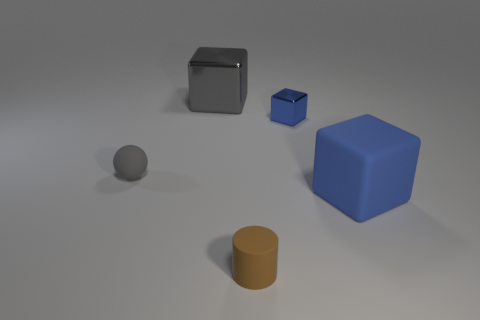Add 4 green metallic cylinders. How many objects exist? 9 Subtract all cylinders. How many objects are left? 4 Add 5 tiny red metallic spheres. How many tiny red metallic spheres exist? 5 Subtract 0 red blocks. How many objects are left? 5 Subtract all tiny brown objects. Subtract all rubber cubes. How many objects are left? 3 Add 4 gray things. How many gray things are left? 6 